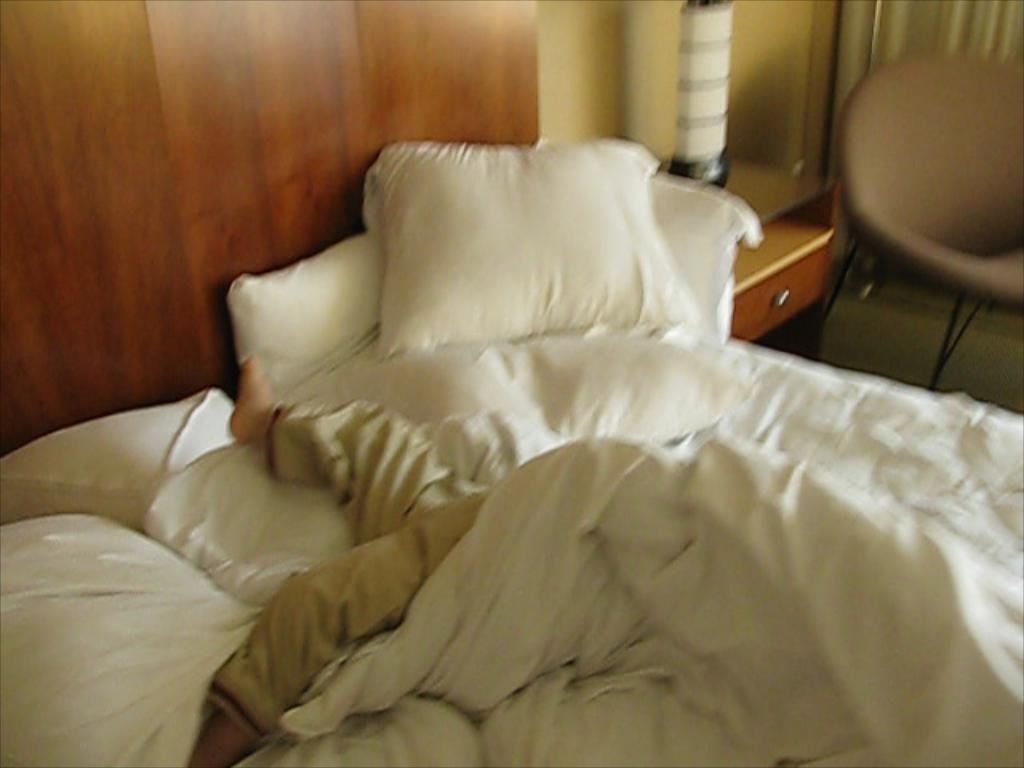Please provide a concise description of this image. In this image i can see a person sleeping in his bed and i can see some pillows on the bed. In the background i can see a couch, a desk and a wooden wall. 